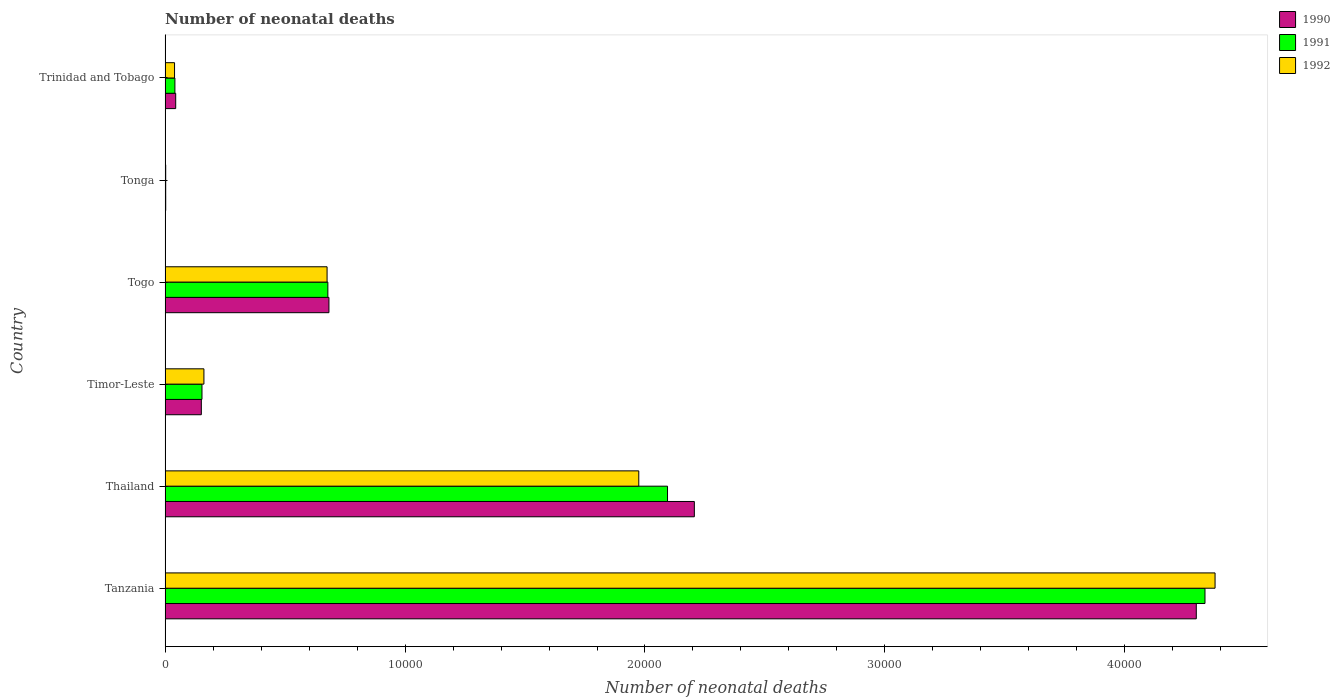Are the number of bars per tick equal to the number of legend labels?
Offer a very short reply. Yes. Are the number of bars on each tick of the Y-axis equal?
Your answer should be compact. Yes. What is the label of the 6th group of bars from the top?
Offer a very short reply. Tanzania. In how many cases, is the number of bars for a given country not equal to the number of legend labels?
Keep it short and to the point. 0. What is the number of neonatal deaths in in 1992 in Thailand?
Keep it short and to the point. 1.97e+04. Across all countries, what is the maximum number of neonatal deaths in in 1990?
Give a very brief answer. 4.30e+04. Across all countries, what is the minimum number of neonatal deaths in in 1991?
Make the answer very short. 25. In which country was the number of neonatal deaths in in 1990 maximum?
Offer a terse response. Tanzania. In which country was the number of neonatal deaths in in 1990 minimum?
Keep it short and to the point. Tonga. What is the total number of neonatal deaths in in 1991 in the graph?
Provide a succinct answer. 7.30e+04. What is the difference between the number of neonatal deaths in in 1990 in Tanzania and that in Togo?
Provide a short and direct response. 3.61e+04. What is the difference between the number of neonatal deaths in in 1990 in Thailand and the number of neonatal deaths in in 1991 in Tanzania?
Your answer should be compact. -2.13e+04. What is the average number of neonatal deaths in in 1991 per country?
Ensure brevity in your answer.  1.22e+04. What is the difference between the number of neonatal deaths in in 1992 and number of neonatal deaths in in 1991 in Tanzania?
Keep it short and to the point. 420. In how many countries, is the number of neonatal deaths in in 1990 greater than 22000 ?
Ensure brevity in your answer.  2. What is the ratio of the number of neonatal deaths in in 1992 in Tanzania to that in Trinidad and Tobago?
Your response must be concise. 111.06. Is the number of neonatal deaths in in 1992 in Timor-Leste less than that in Tonga?
Offer a terse response. No. Is the difference between the number of neonatal deaths in in 1992 in Timor-Leste and Tonga greater than the difference between the number of neonatal deaths in in 1991 in Timor-Leste and Tonga?
Your answer should be compact. Yes. What is the difference between the highest and the second highest number of neonatal deaths in in 1992?
Provide a succinct answer. 2.40e+04. What is the difference between the highest and the lowest number of neonatal deaths in in 1992?
Provide a succinct answer. 4.37e+04. Is the sum of the number of neonatal deaths in in 1992 in Timor-Leste and Tonga greater than the maximum number of neonatal deaths in in 1990 across all countries?
Ensure brevity in your answer.  No. What does the 1st bar from the bottom in Trinidad and Tobago represents?
Offer a terse response. 1990. How many bars are there?
Make the answer very short. 18. Are all the bars in the graph horizontal?
Make the answer very short. Yes. What is the difference between two consecutive major ticks on the X-axis?
Offer a terse response. 10000. Does the graph contain grids?
Make the answer very short. No. Where does the legend appear in the graph?
Your answer should be compact. Top right. How many legend labels are there?
Offer a terse response. 3. How are the legend labels stacked?
Offer a terse response. Vertical. What is the title of the graph?
Offer a very short reply. Number of neonatal deaths. What is the label or title of the X-axis?
Ensure brevity in your answer.  Number of neonatal deaths. What is the label or title of the Y-axis?
Your response must be concise. Country. What is the Number of neonatal deaths of 1990 in Tanzania?
Your response must be concise. 4.30e+04. What is the Number of neonatal deaths in 1991 in Tanzania?
Your response must be concise. 4.33e+04. What is the Number of neonatal deaths of 1992 in Tanzania?
Keep it short and to the point. 4.38e+04. What is the Number of neonatal deaths of 1990 in Thailand?
Offer a very short reply. 2.21e+04. What is the Number of neonatal deaths of 1991 in Thailand?
Offer a terse response. 2.09e+04. What is the Number of neonatal deaths in 1992 in Thailand?
Offer a very short reply. 1.97e+04. What is the Number of neonatal deaths of 1990 in Timor-Leste?
Your answer should be very brief. 1510. What is the Number of neonatal deaths in 1991 in Timor-Leste?
Provide a succinct answer. 1537. What is the Number of neonatal deaths in 1992 in Timor-Leste?
Offer a terse response. 1618. What is the Number of neonatal deaths of 1990 in Togo?
Provide a succinct answer. 6828. What is the Number of neonatal deaths of 1991 in Togo?
Your response must be concise. 6783. What is the Number of neonatal deaths of 1992 in Togo?
Provide a succinct answer. 6751. What is the Number of neonatal deaths in 1991 in Tonga?
Ensure brevity in your answer.  25. What is the Number of neonatal deaths of 1990 in Trinidad and Tobago?
Offer a very short reply. 442. What is the Number of neonatal deaths in 1991 in Trinidad and Tobago?
Your answer should be compact. 409. What is the Number of neonatal deaths of 1992 in Trinidad and Tobago?
Your answer should be compact. 394. Across all countries, what is the maximum Number of neonatal deaths of 1990?
Provide a succinct answer. 4.30e+04. Across all countries, what is the maximum Number of neonatal deaths of 1991?
Make the answer very short. 4.33e+04. Across all countries, what is the maximum Number of neonatal deaths of 1992?
Offer a very short reply. 4.38e+04. Across all countries, what is the minimum Number of neonatal deaths in 1992?
Offer a terse response. 25. What is the total Number of neonatal deaths of 1990 in the graph?
Keep it short and to the point. 7.38e+04. What is the total Number of neonatal deaths in 1991 in the graph?
Ensure brevity in your answer.  7.30e+04. What is the total Number of neonatal deaths of 1992 in the graph?
Your answer should be very brief. 7.23e+04. What is the difference between the Number of neonatal deaths in 1990 in Tanzania and that in Thailand?
Your answer should be compact. 2.09e+04. What is the difference between the Number of neonatal deaths of 1991 in Tanzania and that in Thailand?
Your answer should be compact. 2.24e+04. What is the difference between the Number of neonatal deaths of 1992 in Tanzania and that in Thailand?
Offer a very short reply. 2.40e+04. What is the difference between the Number of neonatal deaths in 1990 in Tanzania and that in Timor-Leste?
Your answer should be compact. 4.15e+04. What is the difference between the Number of neonatal deaths of 1991 in Tanzania and that in Timor-Leste?
Provide a succinct answer. 4.18e+04. What is the difference between the Number of neonatal deaths of 1992 in Tanzania and that in Timor-Leste?
Make the answer very short. 4.21e+04. What is the difference between the Number of neonatal deaths in 1990 in Tanzania and that in Togo?
Keep it short and to the point. 3.61e+04. What is the difference between the Number of neonatal deaths in 1991 in Tanzania and that in Togo?
Provide a succinct answer. 3.66e+04. What is the difference between the Number of neonatal deaths of 1992 in Tanzania and that in Togo?
Make the answer very short. 3.70e+04. What is the difference between the Number of neonatal deaths of 1990 in Tanzania and that in Tonga?
Offer a very short reply. 4.30e+04. What is the difference between the Number of neonatal deaths of 1991 in Tanzania and that in Tonga?
Provide a succinct answer. 4.33e+04. What is the difference between the Number of neonatal deaths in 1992 in Tanzania and that in Tonga?
Your answer should be compact. 4.37e+04. What is the difference between the Number of neonatal deaths of 1990 in Tanzania and that in Trinidad and Tobago?
Give a very brief answer. 4.25e+04. What is the difference between the Number of neonatal deaths in 1991 in Tanzania and that in Trinidad and Tobago?
Keep it short and to the point. 4.29e+04. What is the difference between the Number of neonatal deaths of 1992 in Tanzania and that in Trinidad and Tobago?
Provide a short and direct response. 4.34e+04. What is the difference between the Number of neonatal deaths of 1990 in Thailand and that in Timor-Leste?
Your answer should be compact. 2.05e+04. What is the difference between the Number of neonatal deaths of 1991 in Thailand and that in Timor-Leste?
Provide a short and direct response. 1.94e+04. What is the difference between the Number of neonatal deaths in 1992 in Thailand and that in Timor-Leste?
Provide a short and direct response. 1.81e+04. What is the difference between the Number of neonatal deaths in 1990 in Thailand and that in Togo?
Ensure brevity in your answer.  1.52e+04. What is the difference between the Number of neonatal deaths in 1991 in Thailand and that in Togo?
Provide a succinct answer. 1.42e+04. What is the difference between the Number of neonatal deaths in 1992 in Thailand and that in Togo?
Provide a short and direct response. 1.30e+04. What is the difference between the Number of neonatal deaths of 1990 in Thailand and that in Tonga?
Your answer should be very brief. 2.20e+04. What is the difference between the Number of neonatal deaths in 1991 in Thailand and that in Tonga?
Provide a short and direct response. 2.09e+04. What is the difference between the Number of neonatal deaths of 1992 in Thailand and that in Tonga?
Ensure brevity in your answer.  1.97e+04. What is the difference between the Number of neonatal deaths in 1990 in Thailand and that in Trinidad and Tobago?
Offer a terse response. 2.16e+04. What is the difference between the Number of neonatal deaths of 1991 in Thailand and that in Trinidad and Tobago?
Make the answer very short. 2.05e+04. What is the difference between the Number of neonatal deaths in 1992 in Thailand and that in Trinidad and Tobago?
Give a very brief answer. 1.93e+04. What is the difference between the Number of neonatal deaths of 1990 in Timor-Leste and that in Togo?
Keep it short and to the point. -5318. What is the difference between the Number of neonatal deaths of 1991 in Timor-Leste and that in Togo?
Make the answer very short. -5246. What is the difference between the Number of neonatal deaths in 1992 in Timor-Leste and that in Togo?
Offer a terse response. -5133. What is the difference between the Number of neonatal deaths in 1990 in Timor-Leste and that in Tonga?
Keep it short and to the point. 1484. What is the difference between the Number of neonatal deaths in 1991 in Timor-Leste and that in Tonga?
Make the answer very short. 1512. What is the difference between the Number of neonatal deaths in 1992 in Timor-Leste and that in Tonga?
Offer a terse response. 1593. What is the difference between the Number of neonatal deaths in 1990 in Timor-Leste and that in Trinidad and Tobago?
Your response must be concise. 1068. What is the difference between the Number of neonatal deaths of 1991 in Timor-Leste and that in Trinidad and Tobago?
Offer a very short reply. 1128. What is the difference between the Number of neonatal deaths in 1992 in Timor-Leste and that in Trinidad and Tobago?
Your response must be concise. 1224. What is the difference between the Number of neonatal deaths in 1990 in Togo and that in Tonga?
Offer a terse response. 6802. What is the difference between the Number of neonatal deaths in 1991 in Togo and that in Tonga?
Give a very brief answer. 6758. What is the difference between the Number of neonatal deaths of 1992 in Togo and that in Tonga?
Ensure brevity in your answer.  6726. What is the difference between the Number of neonatal deaths in 1990 in Togo and that in Trinidad and Tobago?
Provide a succinct answer. 6386. What is the difference between the Number of neonatal deaths in 1991 in Togo and that in Trinidad and Tobago?
Make the answer very short. 6374. What is the difference between the Number of neonatal deaths in 1992 in Togo and that in Trinidad and Tobago?
Provide a short and direct response. 6357. What is the difference between the Number of neonatal deaths of 1990 in Tonga and that in Trinidad and Tobago?
Offer a terse response. -416. What is the difference between the Number of neonatal deaths in 1991 in Tonga and that in Trinidad and Tobago?
Ensure brevity in your answer.  -384. What is the difference between the Number of neonatal deaths in 1992 in Tonga and that in Trinidad and Tobago?
Your response must be concise. -369. What is the difference between the Number of neonatal deaths of 1990 in Tanzania and the Number of neonatal deaths of 1991 in Thailand?
Your answer should be compact. 2.20e+04. What is the difference between the Number of neonatal deaths in 1990 in Tanzania and the Number of neonatal deaths in 1992 in Thailand?
Offer a very short reply. 2.32e+04. What is the difference between the Number of neonatal deaths in 1991 in Tanzania and the Number of neonatal deaths in 1992 in Thailand?
Provide a short and direct response. 2.36e+04. What is the difference between the Number of neonatal deaths in 1990 in Tanzania and the Number of neonatal deaths in 1991 in Timor-Leste?
Your answer should be very brief. 4.14e+04. What is the difference between the Number of neonatal deaths of 1990 in Tanzania and the Number of neonatal deaths of 1992 in Timor-Leste?
Offer a very short reply. 4.14e+04. What is the difference between the Number of neonatal deaths of 1991 in Tanzania and the Number of neonatal deaths of 1992 in Timor-Leste?
Provide a succinct answer. 4.17e+04. What is the difference between the Number of neonatal deaths in 1990 in Tanzania and the Number of neonatal deaths in 1991 in Togo?
Your answer should be very brief. 3.62e+04. What is the difference between the Number of neonatal deaths in 1990 in Tanzania and the Number of neonatal deaths in 1992 in Togo?
Provide a succinct answer. 3.62e+04. What is the difference between the Number of neonatal deaths of 1991 in Tanzania and the Number of neonatal deaths of 1992 in Togo?
Your response must be concise. 3.66e+04. What is the difference between the Number of neonatal deaths of 1990 in Tanzania and the Number of neonatal deaths of 1991 in Tonga?
Offer a very short reply. 4.30e+04. What is the difference between the Number of neonatal deaths of 1990 in Tanzania and the Number of neonatal deaths of 1992 in Tonga?
Make the answer very short. 4.30e+04. What is the difference between the Number of neonatal deaths in 1991 in Tanzania and the Number of neonatal deaths in 1992 in Tonga?
Offer a terse response. 4.33e+04. What is the difference between the Number of neonatal deaths in 1990 in Tanzania and the Number of neonatal deaths in 1991 in Trinidad and Tobago?
Provide a succinct answer. 4.26e+04. What is the difference between the Number of neonatal deaths in 1990 in Tanzania and the Number of neonatal deaths in 1992 in Trinidad and Tobago?
Make the answer very short. 4.26e+04. What is the difference between the Number of neonatal deaths of 1991 in Tanzania and the Number of neonatal deaths of 1992 in Trinidad and Tobago?
Ensure brevity in your answer.  4.29e+04. What is the difference between the Number of neonatal deaths of 1990 in Thailand and the Number of neonatal deaths of 1991 in Timor-Leste?
Make the answer very short. 2.05e+04. What is the difference between the Number of neonatal deaths in 1990 in Thailand and the Number of neonatal deaths in 1992 in Timor-Leste?
Offer a terse response. 2.04e+04. What is the difference between the Number of neonatal deaths in 1991 in Thailand and the Number of neonatal deaths in 1992 in Timor-Leste?
Make the answer very short. 1.93e+04. What is the difference between the Number of neonatal deaths of 1990 in Thailand and the Number of neonatal deaths of 1991 in Togo?
Give a very brief answer. 1.53e+04. What is the difference between the Number of neonatal deaths of 1990 in Thailand and the Number of neonatal deaths of 1992 in Togo?
Offer a very short reply. 1.53e+04. What is the difference between the Number of neonatal deaths in 1991 in Thailand and the Number of neonatal deaths in 1992 in Togo?
Your answer should be compact. 1.42e+04. What is the difference between the Number of neonatal deaths in 1990 in Thailand and the Number of neonatal deaths in 1991 in Tonga?
Make the answer very short. 2.20e+04. What is the difference between the Number of neonatal deaths of 1990 in Thailand and the Number of neonatal deaths of 1992 in Tonga?
Make the answer very short. 2.20e+04. What is the difference between the Number of neonatal deaths in 1991 in Thailand and the Number of neonatal deaths in 1992 in Tonga?
Offer a very short reply. 2.09e+04. What is the difference between the Number of neonatal deaths of 1990 in Thailand and the Number of neonatal deaths of 1991 in Trinidad and Tobago?
Your answer should be compact. 2.16e+04. What is the difference between the Number of neonatal deaths of 1990 in Thailand and the Number of neonatal deaths of 1992 in Trinidad and Tobago?
Offer a very short reply. 2.17e+04. What is the difference between the Number of neonatal deaths of 1991 in Thailand and the Number of neonatal deaths of 1992 in Trinidad and Tobago?
Provide a short and direct response. 2.05e+04. What is the difference between the Number of neonatal deaths of 1990 in Timor-Leste and the Number of neonatal deaths of 1991 in Togo?
Provide a short and direct response. -5273. What is the difference between the Number of neonatal deaths in 1990 in Timor-Leste and the Number of neonatal deaths in 1992 in Togo?
Give a very brief answer. -5241. What is the difference between the Number of neonatal deaths in 1991 in Timor-Leste and the Number of neonatal deaths in 1992 in Togo?
Offer a terse response. -5214. What is the difference between the Number of neonatal deaths in 1990 in Timor-Leste and the Number of neonatal deaths in 1991 in Tonga?
Your answer should be very brief. 1485. What is the difference between the Number of neonatal deaths of 1990 in Timor-Leste and the Number of neonatal deaths of 1992 in Tonga?
Your response must be concise. 1485. What is the difference between the Number of neonatal deaths in 1991 in Timor-Leste and the Number of neonatal deaths in 1992 in Tonga?
Your answer should be compact. 1512. What is the difference between the Number of neonatal deaths of 1990 in Timor-Leste and the Number of neonatal deaths of 1991 in Trinidad and Tobago?
Provide a short and direct response. 1101. What is the difference between the Number of neonatal deaths of 1990 in Timor-Leste and the Number of neonatal deaths of 1992 in Trinidad and Tobago?
Your answer should be compact. 1116. What is the difference between the Number of neonatal deaths in 1991 in Timor-Leste and the Number of neonatal deaths in 1992 in Trinidad and Tobago?
Give a very brief answer. 1143. What is the difference between the Number of neonatal deaths of 1990 in Togo and the Number of neonatal deaths of 1991 in Tonga?
Ensure brevity in your answer.  6803. What is the difference between the Number of neonatal deaths of 1990 in Togo and the Number of neonatal deaths of 1992 in Tonga?
Provide a short and direct response. 6803. What is the difference between the Number of neonatal deaths in 1991 in Togo and the Number of neonatal deaths in 1992 in Tonga?
Provide a short and direct response. 6758. What is the difference between the Number of neonatal deaths in 1990 in Togo and the Number of neonatal deaths in 1991 in Trinidad and Tobago?
Offer a terse response. 6419. What is the difference between the Number of neonatal deaths in 1990 in Togo and the Number of neonatal deaths in 1992 in Trinidad and Tobago?
Provide a succinct answer. 6434. What is the difference between the Number of neonatal deaths of 1991 in Togo and the Number of neonatal deaths of 1992 in Trinidad and Tobago?
Your response must be concise. 6389. What is the difference between the Number of neonatal deaths in 1990 in Tonga and the Number of neonatal deaths in 1991 in Trinidad and Tobago?
Provide a succinct answer. -383. What is the difference between the Number of neonatal deaths in 1990 in Tonga and the Number of neonatal deaths in 1992 in Trinidad and Tobago?
Your answer should be very brief. -368. What is the difference between the Number of neonatal deaths of 1991 in Tonga and the Number of neonatal deaths of 1992 in Trinidad and Tobago?
Ensure brevity in your answer.  -369. What is the average Number of neonatal deaths in 1990 per country?
Provide a succinct answer. 1.23e+04. What is the average Number of neonatal deaths in 1991 per country?
Provide a short and direct response. 1.22e+04. What is the average Number of neonatal deaths of 1992 per country?
Provide a short and direct response. 1.20e+04. What is the difference between the Number of neonatal deaths in 1990 and Number of neonatal deaths in 1991 in Tanzania?
Keep it short and to the point. -362. What is the difference between the Number of neonatal deaths in 1990 and Number of neonatal deaths in 1992 in Tanzania?
Keep it short and to the point. -782. What is the difference between the Number of neonatal deaths of 1991 and Number of neonatal deaths of 1992 in Tanzania?
Keep it short and to the point. -420. What is the difference between the Number of neonatal deaths of 1990 and Number of neonatal deaths of 1991 in Thailand?
Offer a very short reply. 1118. What is the difference between the Number of neonatal deaths of 1990 and Number of neonatal deaths of 1992 in Thailand?
Give a very brief answer. 2316. What is the difference between the Number of neonatal deaths in 1991 and Number of neonatal deaths in 1992 in Thailand?
Make the answer very short. 1198. What is the difference between the Number of neonatal deaths of 1990 and Number of neonatal deaths of 1992 in Timor-Leste?
Provide a short and direct response. -108. What is the difference between the Number of neonatal deaths of 1991 and Number of neonatal deaths of 1992 in Timor-Leste?
Keep it short and to the point. -81. What is the difference between the Number of neonatal deaths of 1990 and Number of neonatal deaths of 1992 in Togo?
Offer a terse response. 77. What is the difference between the Number of neonatal deaths in 1991 and Number of neonatal deaths in 1992 in Togo?
Provide a succinct answer. 32. What is the difference between the Number of neonatal deaths of 1990 and Number of neonatal deaths of 1992 in Tonga?
Offer a very short reply. 1. What is the difference between the Number of neonatal deaths of 1991 and Number of neonatal deaths of 1992 in Trinidad and Tobago?
Provide a short and direct response. 15. What is the ratio of the Number of neonatal deaths in 1990 in Tanzania to that in Thailand?
Provide a short and direct response. 1.95. What is the ratio of the Number of neonatal deaths of 1991 in Tanzania to that in Thailand?
Your answer should be compact. 2.07. What is the ratio of the Number of neonatal deaths of 1992 in Tanzania to that in Thailand?
Give a very brief answer. 2.22. What is the ratio of the Number of neonatal deaths of 1990 in Tanzania to that in Timor-Leste?
Your answer should be compact. 28.46. What is the ratio of the Number of neonatal deaths of 1991 in Tanzania to that in Timor-Leste?
Give a very brief answer. 28.2. What is the ratio of the Number of neonatal deaths of 1992 in Tanzania to that in Timor-Leste?
Provide a succinct answer. 27.04. What is the ratio of the Number of neonatal deaths in 1990 in Tanzania to that in Togo?
Keep it short and to the point. 6.29. What is the ratio of the Number of neonatal deaths in 1991 in Tanzania to that in Togo?
Keep it short and to the point. 6.39. What is the ratio of the Number of neonatal deaths in 1992 in Tanzania to that in Togo?
Keep it short and to the point. 6.48. What is the ratio of the Number of neonatal deaths in 1990 in Tanzania to that in Tonga?
Offer a very short reply. 1652.92. What is the ratio of the Number of neonatal deaths of 1991 in Tanzania to that in Tonga?
Ensure brevity in your answer.  1733.52. What is the ratio of the Number of neonatal deaths in 1992 in Tanzania to that in Tonga?
Your answer should be very brief. 1750.32. What is the ratio of the Number of neonatal deaths in 1990 in Tanzania to that in Trinidad and Tobago?
Give a very brief answer. 97.23. What is the ratio of the Number of neonatal deaths in 1991 in Tanzania to that in Trinidad and Tobago?
Offer a very short reply. 105.96. What is the ratio of the Number of neonatal deaths of 1992 in Tanzania to that in Trinidad and Tobago?
Your response must be concise. 111.06. What is the ratio of the Number of neonatal deaths in 1990 in Thailand to that in Timor-Leste?
Your response must be concise. 14.61. What is the ratio of the Number of neonatal deaths in 1991 in Thailand to that in Timor-Leste?
Your answer should be very brief. 13.62. What is the ratio of the Number of neonatal deaths of 1992 in Thailand to that in Timor-Leste?
Keep it short and to the point. 12.2. What is the ratio of the Number of neonatal deaths of 1990 in Thailand to that in Togo?
Ensure brevity in your answer.  3.23. What is the ratio of the Number of neonatal deaths in 1991 in Thailand to that in Togo?
Make the answer very short. 3.09. What is the ratio of the Number of neonatal deaths of 1992 in Thailand to that in Togo?
Make the answer very short. 2.92. What is the ratio of the Number of neonatal deaths of 1990 in Thailand to that in Tonga?
Provide a succinct answer. 848.35. What is the ratio of the Number of neonatal deaths of 1991 in Thailand to that in Tonga?
Ensure brevity in your answer.  837.56. What is the ratio of the Number of neonatal deaths of 1992 in Thailand to that in Tonga?
Offer a very short reply. 789.64. What is the ratio of the Number of neonatal deaths of 1990 in Thailand to that in Trinidad and Tobago?
Provide a succinct answer. 49.9. What is the ratio of the Number of neonatal deaths in 1991 in Thailand to that in Trinidad and Tobago?
Make the answer very short. 51.2. What is the ratio of the Number of neonatal deaths in 1992 in Thailand to that in Trinidad and Tobago?
Provide a succinct answer. 50.1. What is the ratio of the Number of neonatal deaths in 1990 in Timor-Leste to that in Togo?
Provide a short and direct response. 0.22. What is the ratio of the Number of neonatal deaths of 1991 in Timor-Leste to that in Togo?
Your answer should be compact. 0.23. What is the ratio of the Number of neonatal deaths in 1992 in Timor-Leste to that in Togo?
Your response must be concise. 0.24. What is the ratio of the Number of neonatal deaths in 1990 in Timor-Leste to that in Tonga?
Ensure brevity in your answer.  58.08. What is the ratio of the Number of neonatal deaths of 1991 in Timor-Leste to that in Tonga?
Offer a very short reply. 61.48. What is the ratio of the Number of neonatal deaths in 1992 in Timor-Leste to that in Tonga?
Ensure brevity in your answer.  64.72. What is the ratio of the Number of neonatal deaths in 1990 in Timor-Leste to that in Trinidad and Tobago?
Ensure brevity in your answer.  3.42. What is the ratio of the Number of neonatal deaths of 1991 in Timor-Leste to that in Trinidad and Tobago?
Offer a terse response. 3.76. What is the ratio of the Number of neonatal deaths of 1992 in Timor-Leste to that in Trinidad and Tobago?
Offer a very short reply. 4.11. What is the ratio of the Number of neonatal deaths of 1990 in Togo to that in Tonga?
Keep it short and to the point. 262.62. What is the ratio of the Number of neonatal deaths of 1991 in Togo to that in Tonga?
Your answer should be compact. 271.32. What is the ratio of the Number of neonatal deaths of 1992 in Togo to that in Tonga?
Make the answer very short. 270.04. What is the ratio of the Number of neonatal deaths in 1990 in Togo to that in Trinidad and Tobago?
Offer a terse response. 15.45. What is the ratio of the Number of neonatal deaths in 1991 in Togo to that in Trinidad and Tobago?
Offer a terse response. 16.58. What is the ratio of the Number of neonatal deaths of 1992 in Togo to that in Trinidad and Tobago?
Your answer should be compact. 17.13. What is the ratio of the Number of neonatal deaths of 1990 in Tonga to that in Trinidad and Tobago?
Your answer should be compact. 0.06. What is the ratio of the Number of neonatal deaths in 1991 in Tonga to that in Trinidad and Tobago?
Your answer should be compact. 0.06. What is the ratio of the Number of neonatal deaths in 1992 in Tonga to that in Trinidad and Tobago?
Make the answer very short. 0.06. What is the difference between the highest and the second highest Number of neonatal deaths of 1990?
Offer a terse response. 2.09e+04. What is the difference between the highest and the second highest Number of neonatal deaths in 1991?
Your answer should be compact. 2.24e+04. What is the difference between the highest and the second highest Number of neonatal deaths of 1992?
Your answer should be very brief. 2.40e+04. What is the difference between the highest and the lowest Number of neonatal deaths of 1990?
Your answer should be compact. 4.30e+04. What is the difference between the highest and the lowest Number of neonatal deaths in 1991?
Make the answer very short. 4.33e+04. What is the difference between the highest and the lowest Number of neonatal deaths of 1992?
Keep it short and to the point. 4.37e+04. 